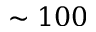<formula> <loc_0><loc_0><loc_500><loc_500>\sim 1 0 0</formula> 